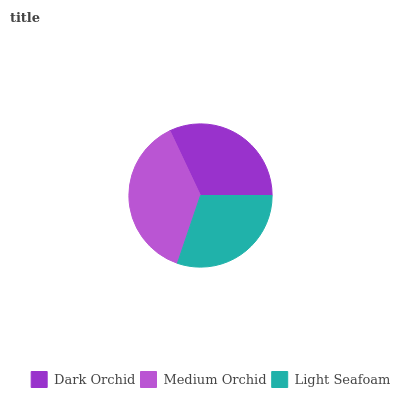Is Light Seafoam the minimum?
Answer yes or no. Yes. Is Medium Orchid the maximum?
Answer yes or no. Yes. Is Medium Orchid the minimum?
Answer yes or no. No. Is Light Seafoam the maximum?
Answer yes or no. No. Is Medium Orchid greater than Light Seafoam?
Answer yes or no. Yes. Is Light Seafoam less than Medium Orchid?
Answer yes or no. Yes. Is Light Seafoam greater than Medium Orchid?
Answer yes or no. No. Is Medium Orchid less than Light Seafoam?
Answer yes or no. No. Is Dark Orchid the high median?
Answer yes or no. Yes. Is Dark Orchid the low median?
Answer yes or no. Yes. Is Medium Orchid the high median?
Answer yes or no. No. Is Medium Orchid the low median?
Answer yes or no. No. 